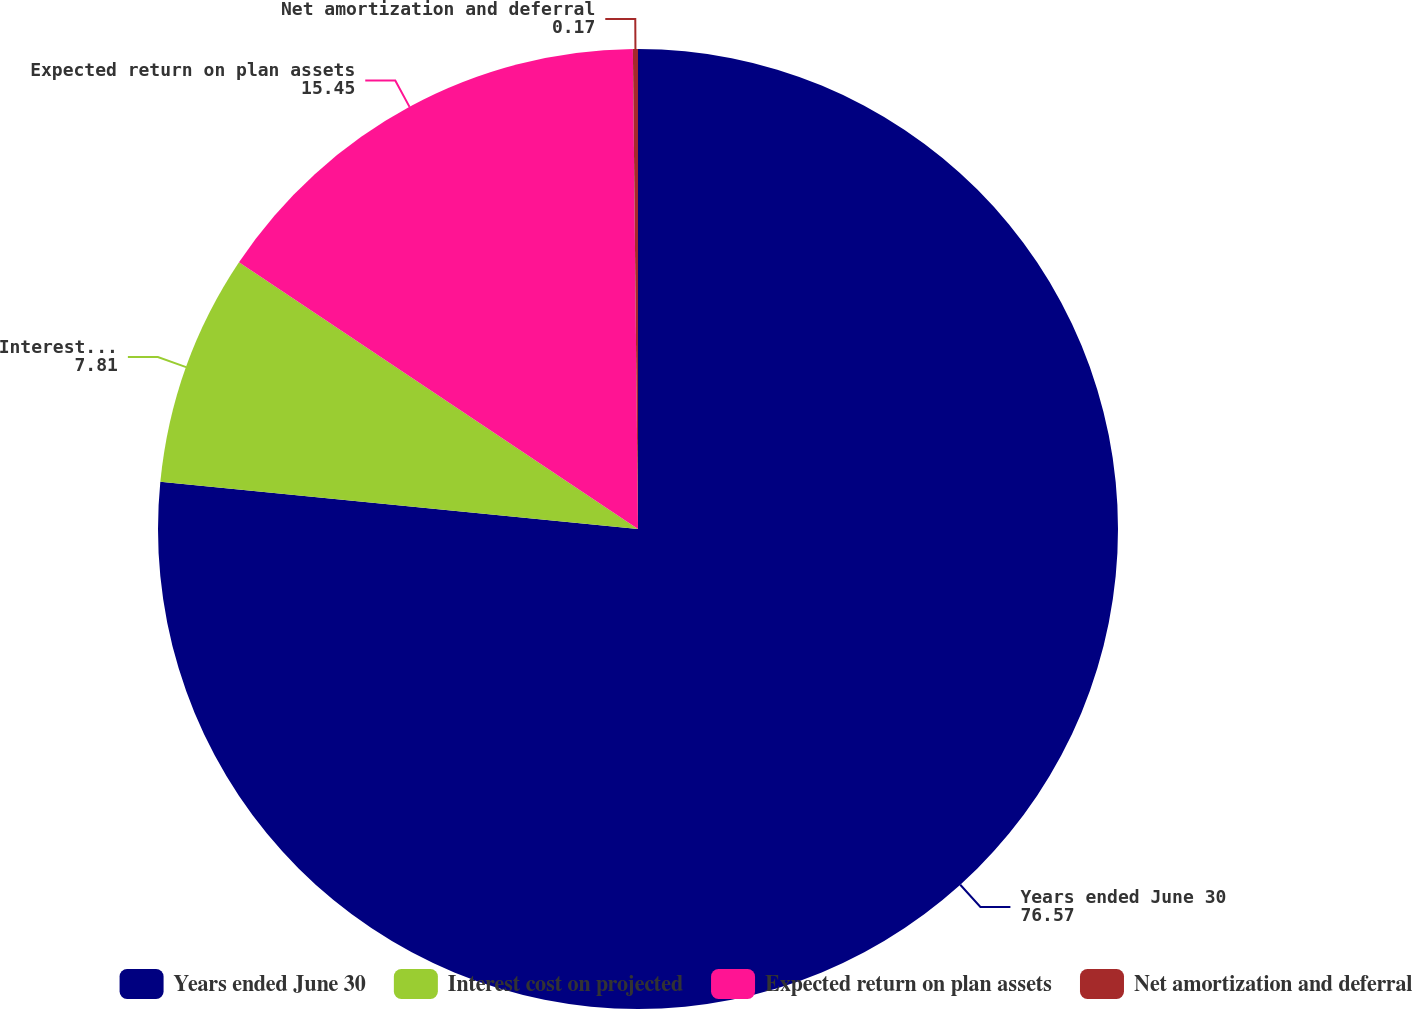Convert chart to OTSL. <chart><loc_0><loc_0><loc_500><loc_500><pie_chart><fcel>Years ended June 30<fcel>Interest cost on projected<fcel>Expected return on plan assets<fcel>Net amortization and deferral<nl><fcel>76.57%<fcel>7.81%<fcel>15.45%<fcel>0.17%<nl></chart> 